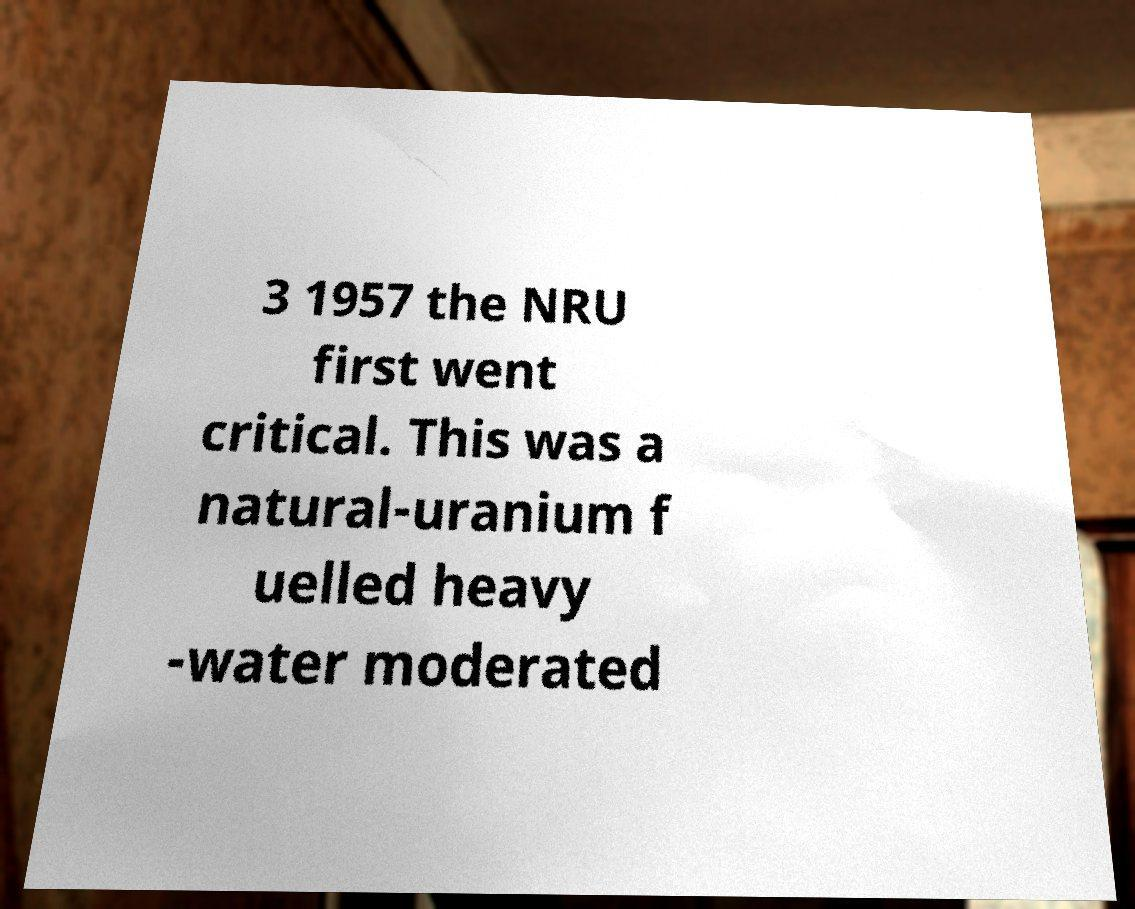Could you assist in decoding the text presented in this image and type it out clearly? 3 1957 the NRU first went critical. This was a natural-uranium f uelled heavy -water moderated 